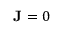Convert formula to latex. <formula><loc_0><loc_0><loc_500><loc_500>J = 0</formula> 